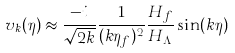<formula> <loc_0><loc_0><loc_500><loc_500>v _ { k } ( \eta ) \approx \frac { - i } { \sqrt { 2 k } } \frac { 1 } { ( k \eta _ { f } ) ^ { 2 } } \frac { H _ { f } } { H _ { \Lambda } } \sin ( k \eta )</formula> 